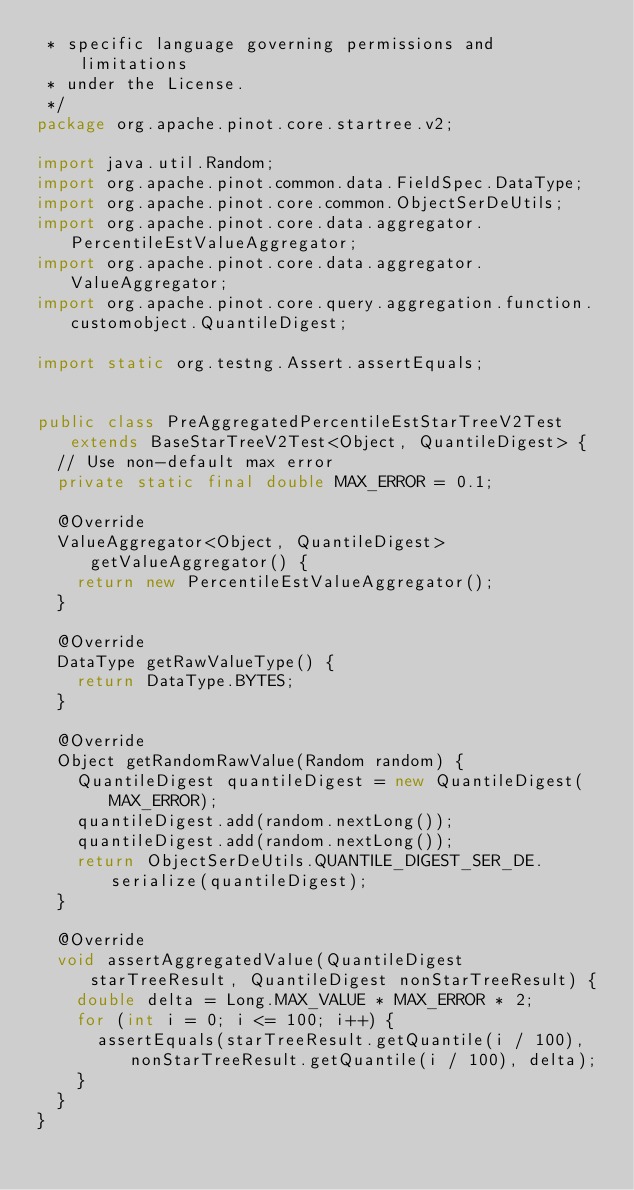Convert code to text. <code><loc_0><loc_0><loc_500><loc_500><_Java_> * specific language governing permissions and limitations
 * under the License.
 */
package org.apache.pinot.core.startree.v2;

import java.util.Random;
import org.apache.pinot.common.data.FieldSpec.DataType;
import org.apache.pinot.core.common.ObjectSerDeUtils;
import org.apache.pinot.core.data.aggregator.PercentileEstValueAggregator;
import org.apache.pinot.core.data.aggregator.ValueAggregator;
import org.apache.pinot.core.query.aggregation.function.customobject.QuantileDigest;

import static org.testng.Assert.assertEquals;


public class PreAggregatedPercentileEstStarTreeV2Test extends BaseStarTreeV2Test<Object, QuantileDigest> {
  // Use non-default max error
  private static final double MAX_ERROR = 0.1;

  @Override
  ValueAggregator<Object, QuantileDigest> getValueAggregator() {
    return new PercentileEstValueAggregator();
  }

  @Override
  DataType getRawValueType() {
    return DataType.BYTES;
  }

  @Override
  Object getRandomRawValue(Random random) {
    QuantileDigest quantileDigest = new QuantileDigest(MAX_ERROR);
    quantileDigest.add(random.nextLong());
    quantileDigest.add(random.nextLong());
    return ObjectSerDeUtils.QUANTILE_DIGEST_SER_DE.serialize(quantileDigest);
  }

  @Override
  void assertAggregatedValue(QuantileDigest starTreeResult, QuantileDigest nonStarTreeResult) {
    double delta = Long.MAX_VALUE * MAX_ERROR * 2;
    for (int i = 0; i <= 100; i++) {
      assertEquals(starTreeResult.getQuantile(i / 100), nonStarTreeResult.getQuantile(i / 100), delta);
    }
  }
}
</code> 